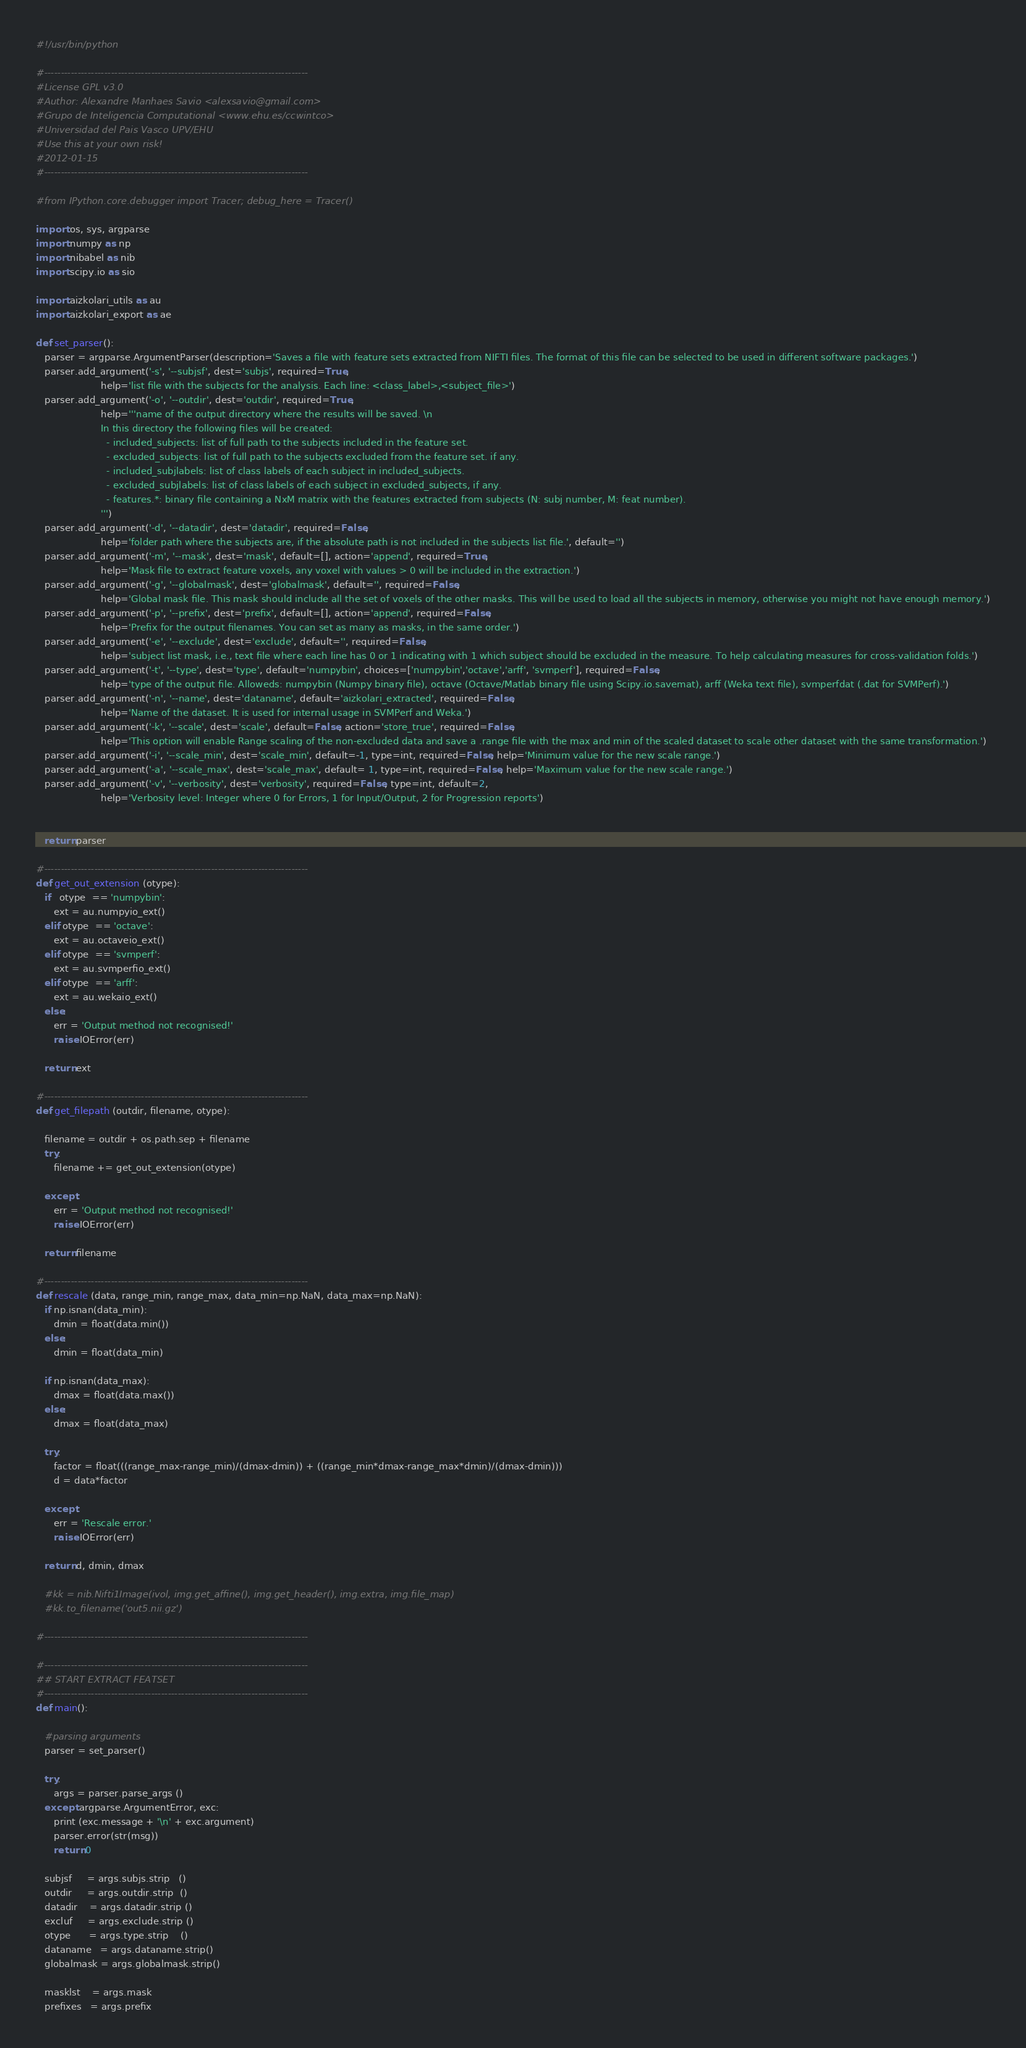<code> <loc_0><loc_0><loc_500><loc_500><_Python_>#!/usr/bin/python

#-------------------------------------------------------------------------------
#License GPL v3.0
#Author: Alexandre Manhaes Savio <alexsavio@gmail.com>
#Grupo de Inteligencia Computational <www.ehu.es/ccwintco>
#Universidad del Pais Vasco UPV/EHU
#Use this at your own risk!
#2012-01-15
#-------------------------------------------------------------------------------

#from IPython.core.debugger import Tracer; debug_here = Tracer()

import os, sys, argparse
import numpy as np
import nibabel as nib
import scipy.io as sio

import aizkolari_utils as au
import aizkolari_export as ae

def set_parser():
   parser = argparse.ArgumentParser(description='Saves a file with feature sets extracted from NIFTI files. The format of this file can be selected to be used in different software packages.')
   parser.add_argument('-s', '--subjsf', dest='subjs', required=True,
                      help='list file with the subjects for the analysis. Each line: <class_label>,<subject_file>')
   parser.add_argument('-o', '--outdir', dest='outdir', required=True,
                      help='''name of the output directory where the results will be saved. \n
                      In this directory the following files will be created:
                        - included_subjects: list of full path to the subjects included in the feature set.
                        - excluded_subjects: list of full path to the subjects excluded from the feature set. if any.
                        - included_subjlabels: list of class labels of each subject in included_subjects.
                        - excluded_subjlabels: list of class labels of each subject in excluded_subjects, if any.
                        - features.*: binary file containing a NxM matrix with the features extracted from subjects (N: subj number, M: feat number).
                      ''')
   parser.add_argument('-d', '--datadir', dest='datadir', required=False,
                      help='folder path where the subjects are, if the absolute path is not included in the subjects list file.', default='')
   parser.add_argument('-m', '--mask', dest='mask', default=[], action='append', required=True,
                      help='Mask file to extract feature voxels, any voxel with values > 0 will be included in the extraction.')
   parser.add_argument('-g', '--globalmask', dest='globalmask', default='', required=False,
                      help='Global mask file. This mask should include all the set of voxels of the other masks. This will be used to load all the subjects in memory, otherwise you might not have enough memory.')
   parser.add_argument('-p', '--prefix', dest='prefix', default=[], action='append', required=False,
                      help='Prefix for the output filenames. You can set as many as masks, in the same order.')
   parser.add_argument('-e', '--exclude', dest='exclude', default='', required=False,
                      help='subject list mask, i.e., text file where each line has 0 or 1 indicating with 1 which subject should be excluded in the measure. To help calculating measures for cross-validation folds.')
   parser.add_argument('-t', '--type', dest='type', default='numpybin', choices=['numpybin','octave','arff', 'svmperf'], required=False,
                      help='type of the output file. Alloweds: numpybin (Numpy binary file), octave (Octave/Matlab binary file using Scipy.io.savemat), arff (Weka text file), svmperfdat (.dat for SVMPerf).')
   parser.add_argument('-n', '--name', dest='dataname', default='aizkolari_extracted', required=False,
                      help='Name of the dataset. It is used for internal usage in SVMPerf and Weka.')
   parser.add_argument('-k', '--scale', dest='scale', default=False, action='store_true', required=False,
                      help='This option will enable Range scaling of the non-excluded data and save a .range file with the max and min of the scaled dataset to scale other dataset with the same transformation.')
   parser.add_argument('-i', '--scale_min', dest='scale_min', default=-1, type=int, required=False, help='Minimum value for the new scale range.')
   parser.add_argument('-a', '--scale_max', dest='scale_max', default= 1, type=int, required=False, help='Maximum value for the new scale range.')
   parser.add_argument('-v', '--verbosity', dest='verbosity', required=False, type=int, default=2,
                      help='Verbosity level: Integer where 0 for Errors, 1 for Input/Output, 2 for Progression reports')


   return parser

#-------------------------------------------------------------------------------
def get_out_extension (otype):
   if   otype  == 'numpybin':
      ext = au.numpyio_ext()
   elif otype  == 'octave':
      ext = au.octaveio_ext()
   elif otype  == 'svmperf':
      ext = au.svmperfio_ext()
   elif otype  == 'arff':
      ext = au.wekaio_ext()
   else:
      err = 'Output method not recognised!'
      raise IOError(err)

   return ext

#-------------------------------------------------------------------------------
def get_filepath (outdir, filename, otype):

   filename = outdir + os.path.sep + filename
   try:
      filename += get_out_extension(otype)

   except:
      err = 'Output method not recognised!'
      raise IOError(err)

   return filename

#-------------------------------------------------------------------------------
def rescale (data, range_min, range_max, data_min=np.NaN, data_max=np.NaN):
   if np.isnan(data_min):
      dmin = float(data.min())
   else:
      dmin = float(data_min)

   if np.isnan(data_max):
      dmax = float(data.max())
   else:
      dmax = float(data_max)

   try:
      factor = float(((range_max-range_min)/(dmax-dmin)) + ((range_min*dmax-range_max*dmin)/(dmax-dmin)))
      d = data*factor

   except:
      err = 'Rescale error.'
      raise IOError(err)

   return d, dmin, dmax

   #kk = nib.Nifti1Image(ivol, img.get_affine(), img.get_header(), img.extra, img.file_map)
   #kk.to_filename('out5.nii.gz')

#-------------------------------------------------------------------------------

#-------------------------------------------------------------------------------
## START EXTRACT FEATSET
#-------------------------------------------------------------------------------
def main():

   #parsing arguments
   parser = set_parser()

   try:
      args = parser.parse_args ()
   except argparse.ArgumentError, exc:
      print (exc.message + '\n' + exc.argument)
      parser.error(str(msg))
      return 0

   subjsf     = args.subjs.strip   ()
   outdir     = args.outdir.strip  ()
   datadir    = args.datadir.strip ()
   excluf     = args.exclude.strip ()
   otype      = args.type.strip    ()
   dataname   = args.dataname.strip()
   globalmask = args.globalmask.strip()

   masklst    = args.mask
   prefixes   = args.prefix</code> 